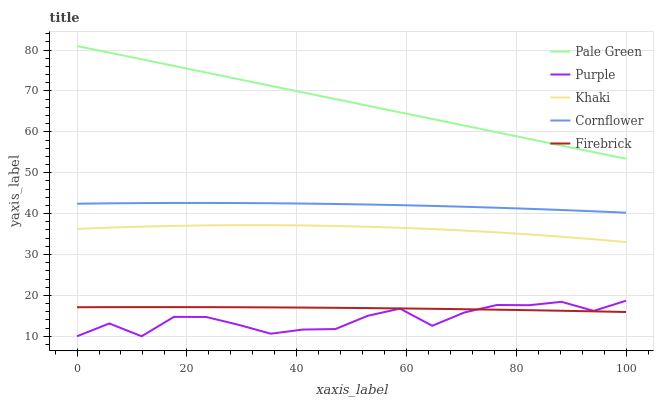Does Purple have the minimum area under the curve?
Answer yes or no. Yes. Does Pale Green have the maximum area under the curve?
Answer yes or no. Yes. Does Cornflower have the minimum area under the curve?
Answer yes or no. No. Does Cornflower have the maximum area under the curve?
Answer yes or no. No. Is Pale Green the smoothest?
Answer yes or no. Yes. Is Purple the roughest?
Answer yes or no. Yes. Is Cornflower the smoothest?
Answer yes or no. No. Is Cornflower the roughest?
Answer yes or no. No. Does Purple have the lowest value?
Answer yes or no. Yes. Does Cornflower have the lowest value?
Answer yes or no. No. Does Pale Green have the highest value?
Answer yes or no. Yes. Does Cornflower have the highest value?
Answer yes or no. No. Is Purple less than Pale Green?
Answer yes or no. Yes. Is Pale Green greater than Khaki?
Answer yes or no. Yes. Does Purple intersect Firebrick?
Answer yes or no. Yes. Is Purple less than Firebrick?
Answer yes or no. No. Is Purple greater than Firebrick?
Answer yes or no. No. Does Purple intersect Pale Green?
Answer yes or no. No. 